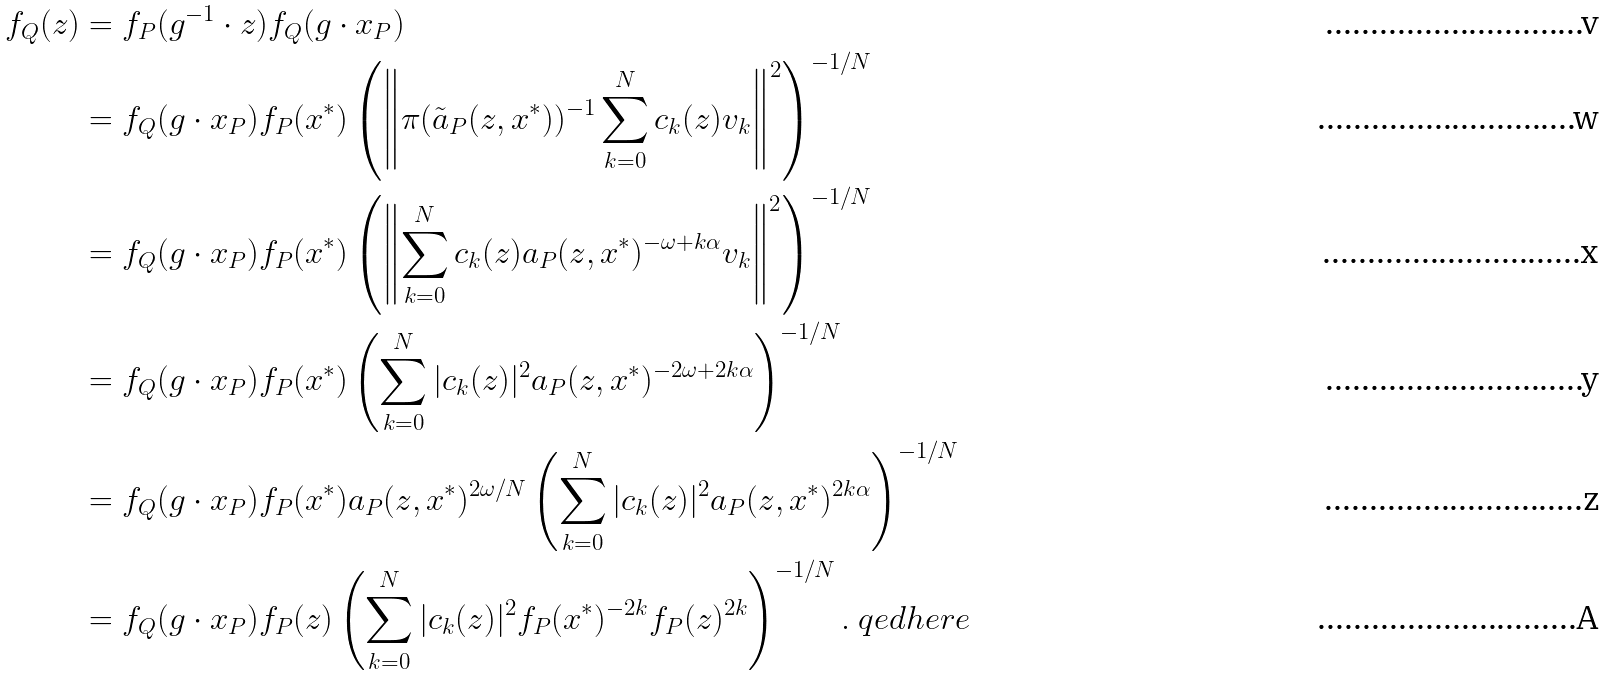Convert formula to latex. <formula><loc_0><loc_0><loc_500><loc_500>f _ { Q } ( z ) & = f _ { P } ( g ^ { - 1 } \cdot z ) f _ { Q } ( g \cdot x _ { P } ) \\ & = f _ { Q } ( g \cdot x _ { P } ) f _ { P } ( { x ^ { * } } ) \left ( \left \| \pi ( \tilde { a } _ { P } ( z , { x ^ { * } } ) ) ^ { - 1 } \sum _ { k = 0 } ^ { N } c _ { k } ( z ) v _ { k } \right \| ^ { 2 } \right ) ^ { - 1 / N } \\ & = f _ { Q } ( g \cdot x _ { P } ) f _ { P } ( { x ^ { * } } ) \left ( \left \| \sum _ { k = 0 } ^ { N } c _ { k } ( z ) a _ { P } ( z , { x ^ { * } } ) ^ { - \omega + k \alpha } v _ { k } \right \| ^ { 2 } \right ) ^ { - 1 / N } \\ & = f _ { Q } ( g \cdot x _ { P } ) f _ { P } ( { x ^ { * } } ) \left ( \sum _ { k = 0 } ^ { N } | c _ { k } ( z ) | ^ { 2 } a _ { P } ( z , { x ^ { * } } ) ^ { - 2 \omega + 2 k \alpha } \right ) ^ { - 1 / N } \\ & = f _ { Q } ( g \cdot x _ { P } ) f _ { P } ( { x ^ { * } } ) a _ { P } ( z , { x ^ { * } } ) ^ { 2 \omega / N } \left ( \sum _ { k = 0 } ^ { N } | c _ { k } ( z ) | ^ { 2 } a _ { P } ( z , { x ^ { * } } ) ^ { 2 k \alpha } \right ) ^ { - 1 / N } \\ & = f _ { Q } ( g \cdot x _ { P } ) f _ { P } ( z ) \left ( \sum _ { k = 0 } ^ { N } | c _ { k } ( z ) | ^ { 2 } f _ { P } ( { x ^ { * } } ) ^ { - 2 k } f _ { P } ( z ) ^ { 2 k } \right ) ^ { - 1 / N } . \ q e d h e r e</formula> 